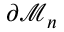Convert formula to latex. <formula><loc_0><loc_0><loc_500><loc_500>\partial \mathcal { M } _ { n }</formula> 